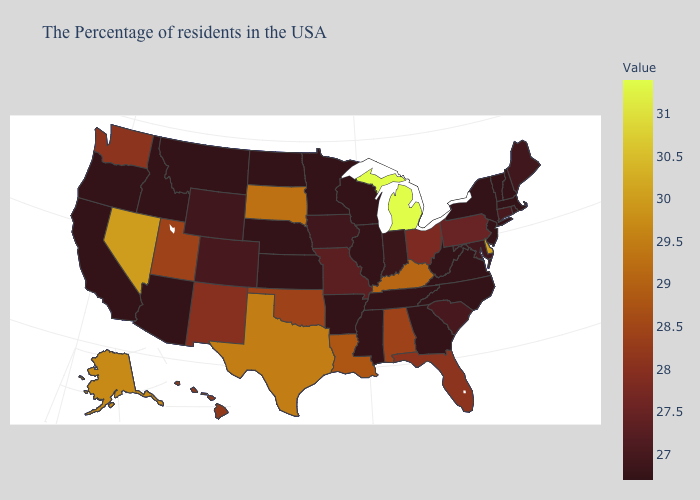Among the states that border Rhode Island , which have the highest value?
Write a very short answer. Connecticut. Does Iowa have the highest value in the MidWest?
Answer briefly. No. Does New York have the lowest value in the Northeast?
Write a very short answer. Yes. Does New Hampshire have the lowest value in the Northeast?
Answer briefly. Yes. Does Massachusetts have the lowest value in the Northeast?
Quick response, please. Yes. Does the map have missing data?
Short answer required. No. Which states have the highest value in the USA?
Be succinct. Michigan. 